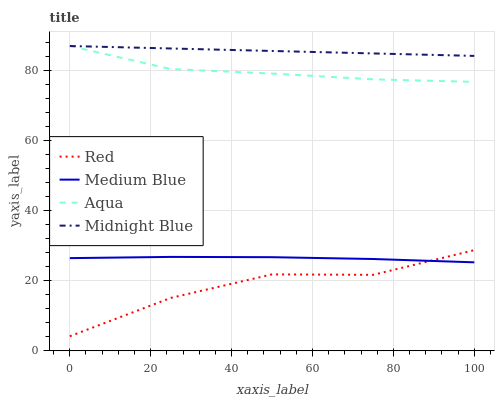Does Red have the minimum area under the curve?
Answer yes or no. Yes. Does Midnight Blue have the maximum area under the curve?
Answer yes or no. Yes. Does Medium Blue have the minimum area under the curve?
Answer yes or no. No. Does Medium Blue have the maximum area under the curve?
Answer yes or no. No. Is Midnight Blue the smoothest?
Answer yes or no. Yes. Is Red the roughest?
Answer yes or no. Yes. Is Medium Blue the smoothest?
Answer yes or no. No. Is Medium Blue the roughest?
Answer yes or no. No. Does Red have the lowest value?
Answer yes or no. Yes. Does Medium Blue have the lowest value?
Answer yes or no. No. Does Midnight Blue have the highest value?
Answer yes or no. Yes. Does Medium Blue have the highest value?
Answer yes or no. No. Is Red less than Aqua?
Answer yes or no. Yes. Is Aqua greater than Red?
Answer yes or no. Yes. Does Midnight Blue intersect Aqua?
Answer yes or no. Yes. Is Midnight Blue less than Aqua?
Answer yes or no. No. Is Midnight Blue greater than Aqua?
Answer yes or no. No. Does Red intersect Aqua?
Answer yes or no. No. 